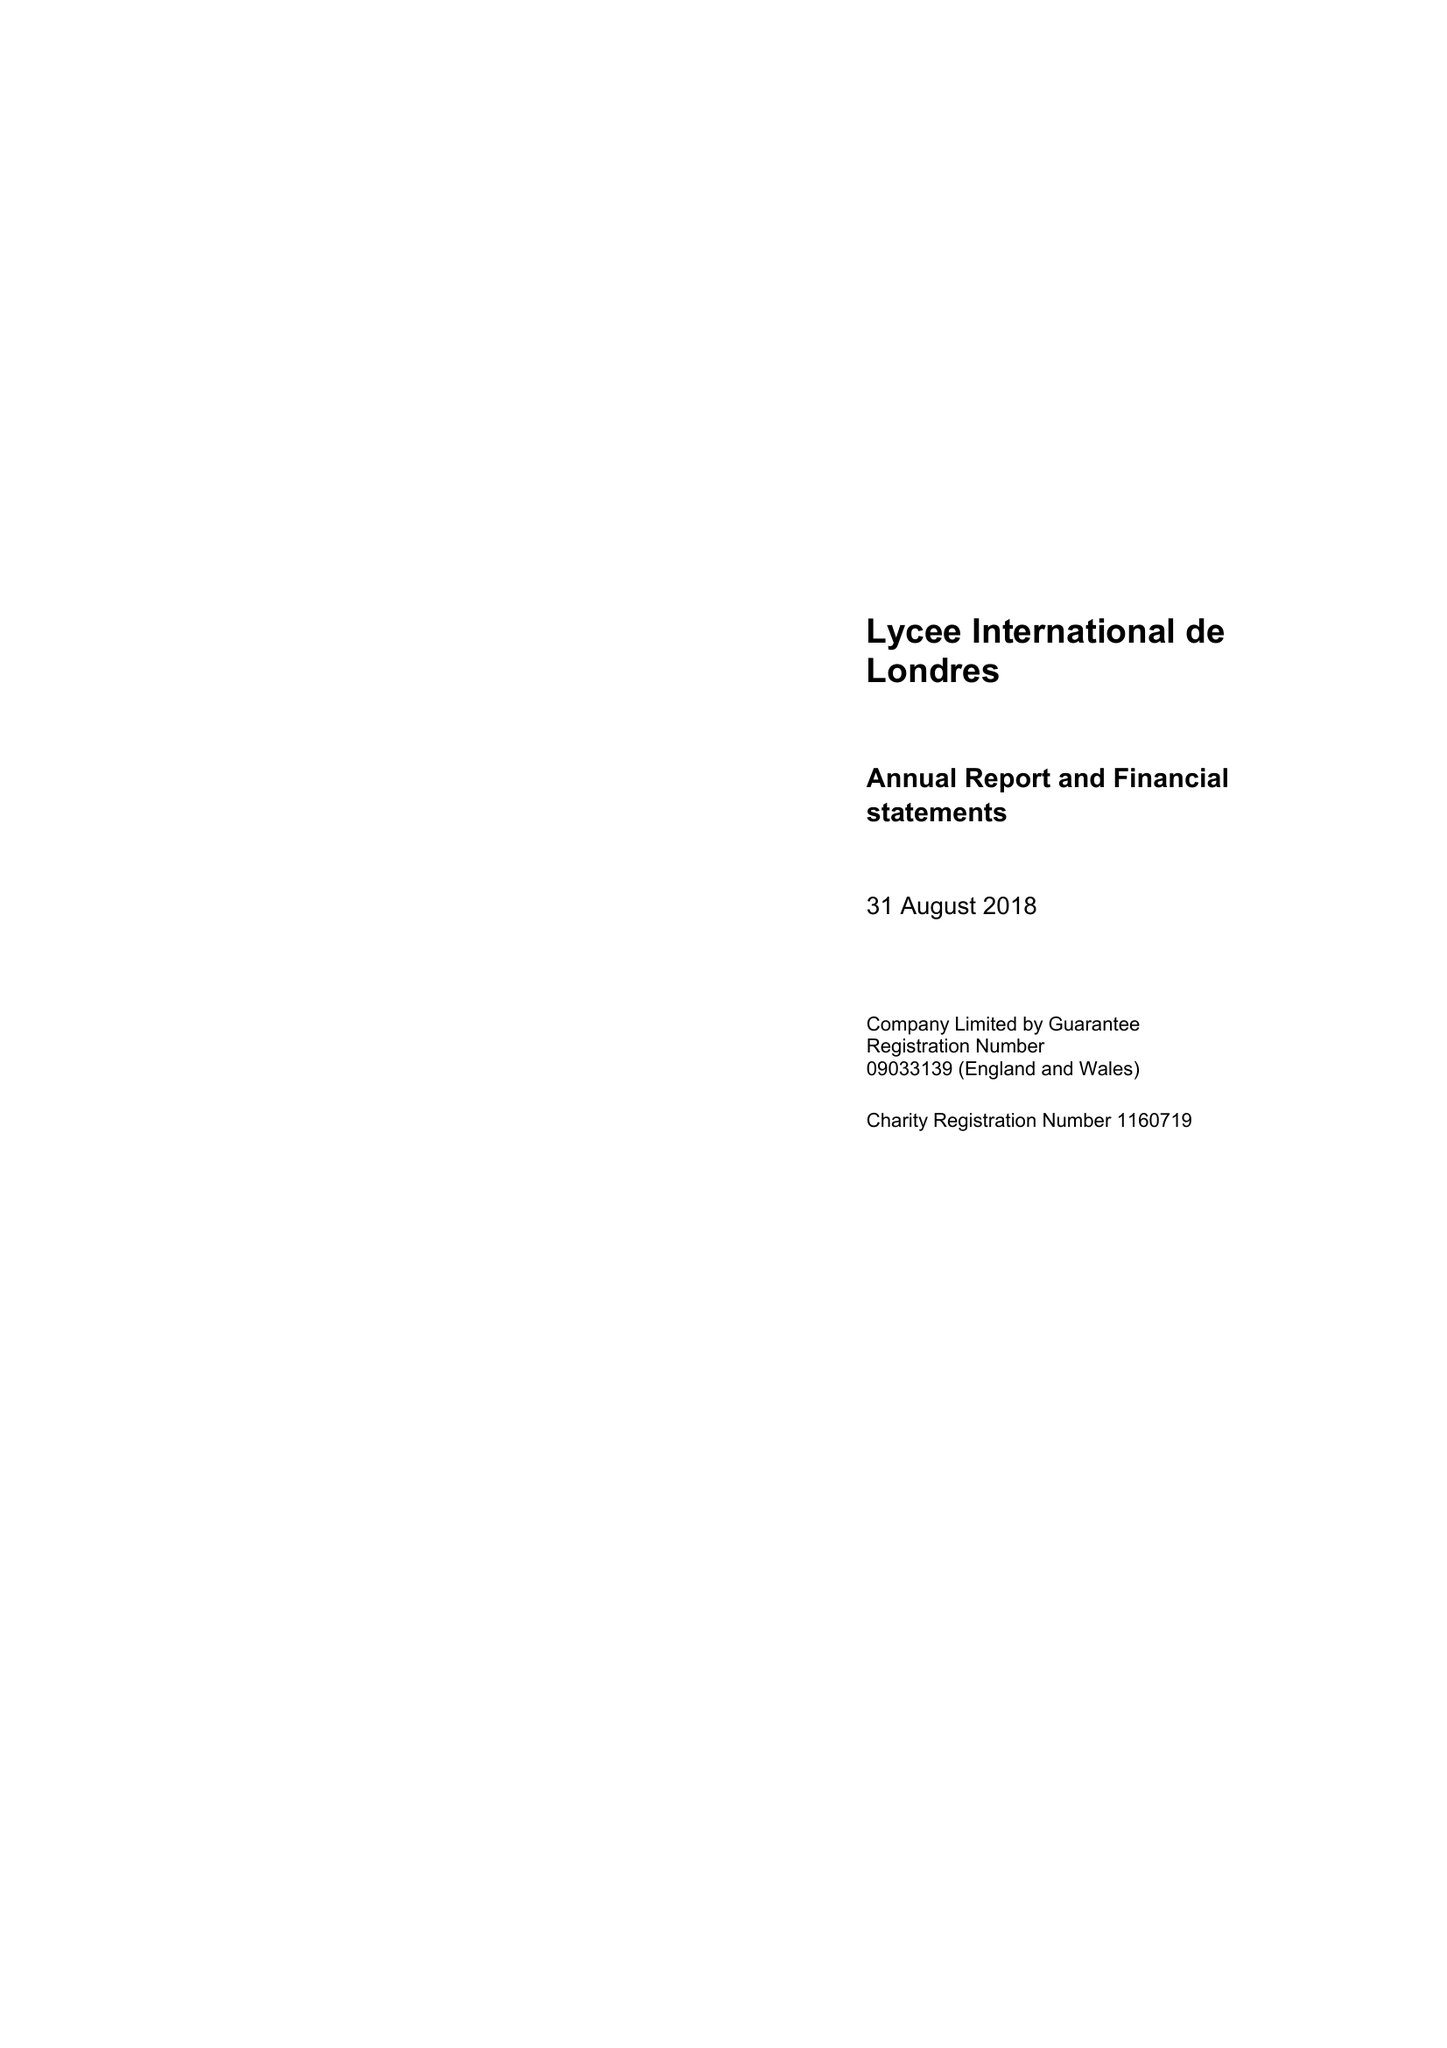What is the value for the address__street_line?
Answer the question using a single word or phrase. 54 FORTY LANE 